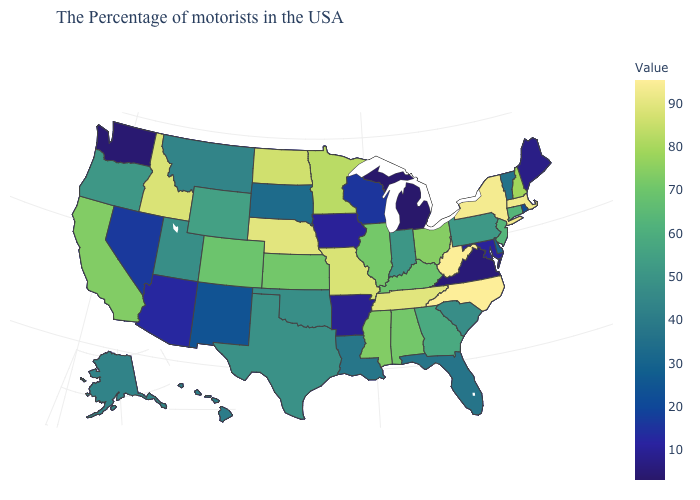Among the states that border Nebraska , which have the highest value?
Quick response, please. Missouri. Does New York have the highest value in the Northeast?
Keep it brief. Yes. Does South Dakota have the highest value in the USA?
Concise answer only. No. Among the states that border Washington , which have the lowest value?
Keep it brief. Oregon. Does New York have the highest value in the Northeast?
Short answer required. Yes. 